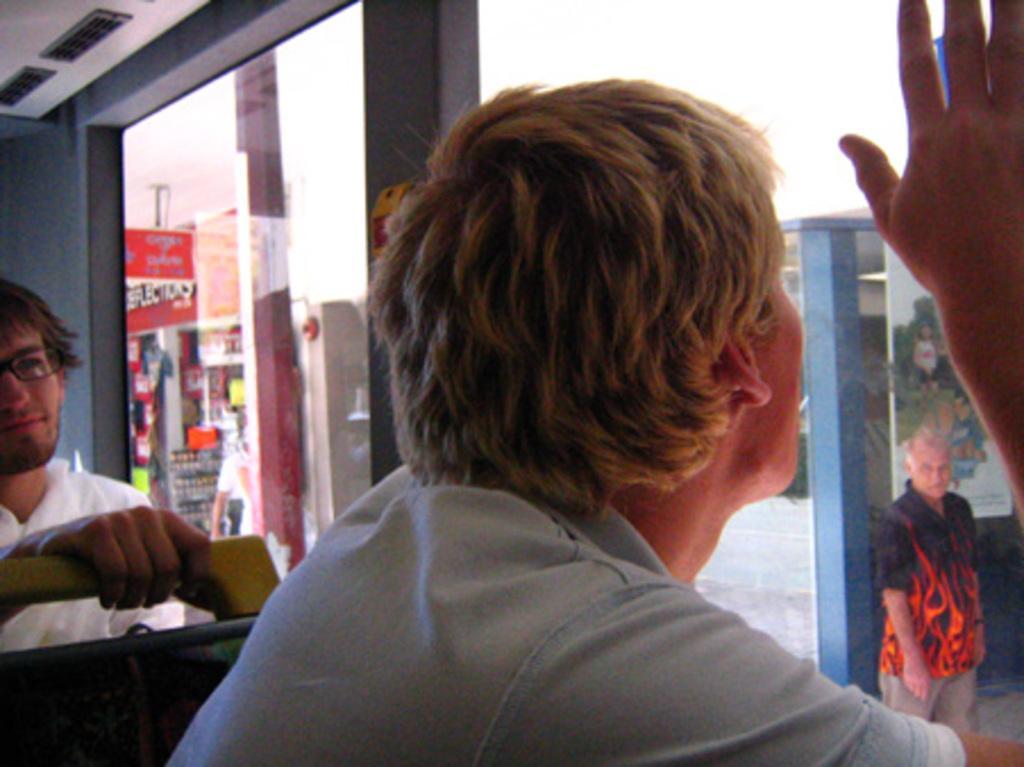Could you give a brief overview of what you see in this image? In the picture I can see a person in the right corner placed his hand on the glass in front of him and there is another person sitting in the left corner and there are some other objects in the background. 